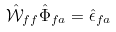<formula> <loc_0><loc_0><loc_500><loc_500>\hat { \mathcal { W } } _ { f f } \hat { \Phi } _ { f a } = \hat { \epsilon } _ { f a }</formula> 